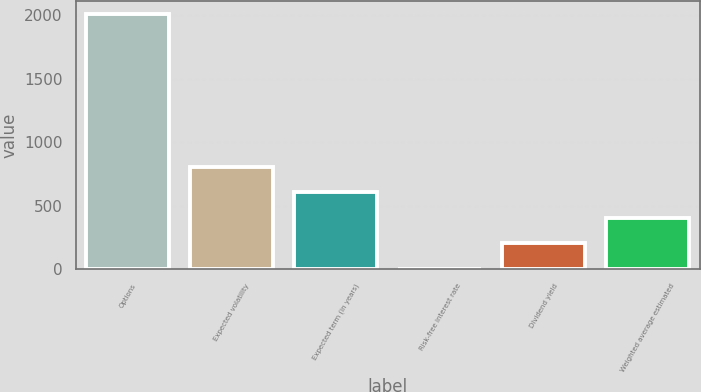Convert chart. <chart><loc_0><loc_0><loc_500><loc_500><bar_chart><fcel>Options<fcel>Expected volatility<fcel>Expected term (in years)<fcel>Risk-free interest rate<fcel>Dividend yield<fcel>Weighted average estimated<nl><fcel>2009<fcel>804.86<fcel>604.17<fcel>2.1<fcel>202.79<fcel>403.48<nl></chart> 